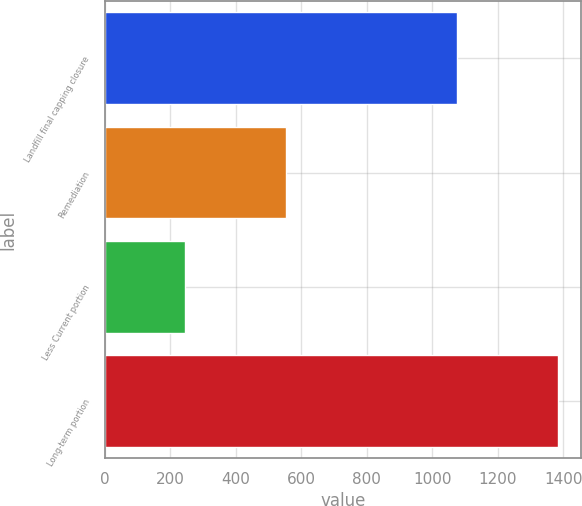Convert chart. <chart><loc_0><loc_0><loc_500><loc_500><bar_chart><fcel>Landfill final capping closure<fcel>Remediation<fcel>Less Current portion<fcel>Long-term portion<nl><fcel>1074.5<fcel>554.1<fcel>245.4<fcel>1383.2<nl></chart> 